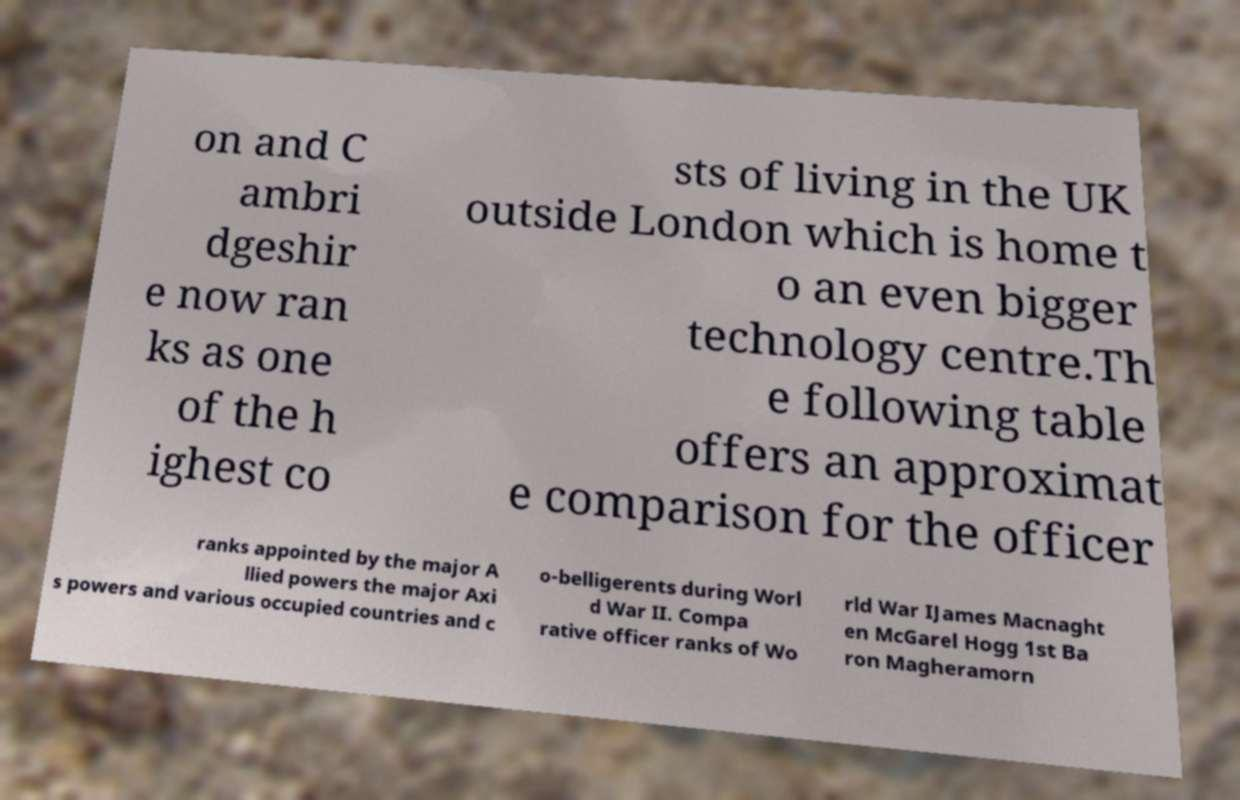For documentation purposes, I need the text within this image transcribed. Could you provide that? on and C ambri dgeshir e now ran ks as one of the h ighest co sts of living in the UK outside London which is home t o an even bigger technology centre.Th e following table offers an approximat e comparison for the officer ranks appointed by the major A llied powers the major Axi s powers and various occupied countries and c o-belligerents during Worl d War II. Compa rative officer ranks of Wo rld War IJames Macnaght en McGarel Hogg 1st Ba ron Magheramorn 